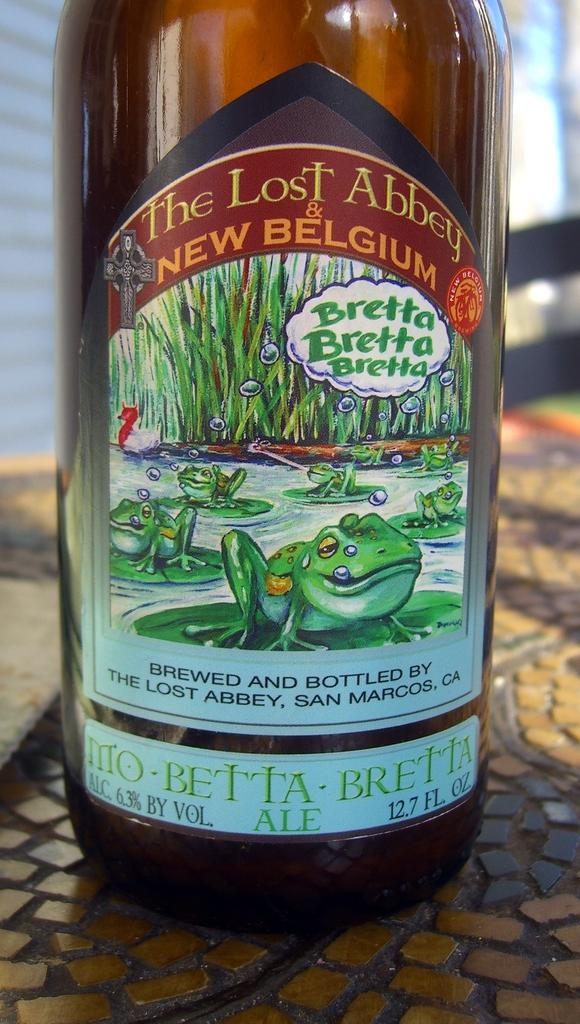<image>
Render a clear and concise summary of the photo. a close up of a bottle of The Lost Abbey & New Belgium Ale 